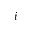Convert formula to latex. <formula><loc_0><loc_0><loc_500><loc_500>i</formula> 